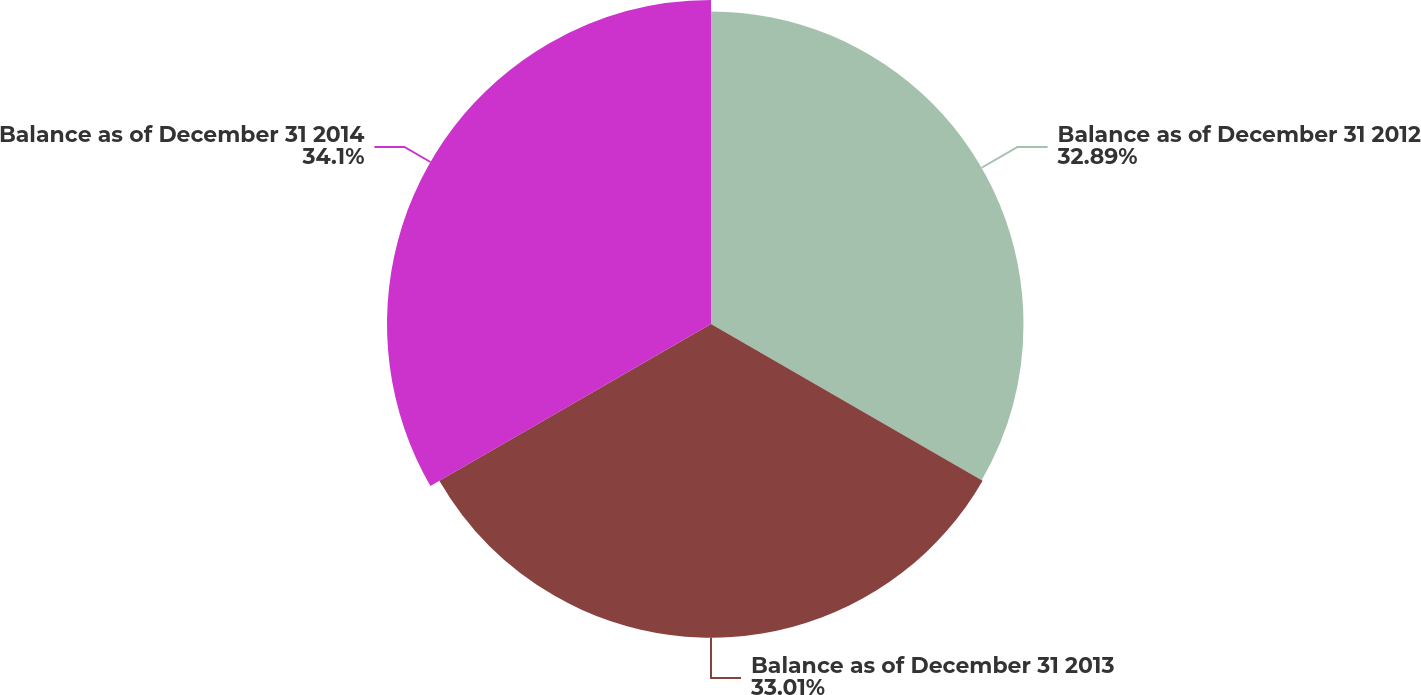Convert chart to OTSL. <chart><loc_0><loc_0><loc_500><loc_500><pie_chart><fcel>Balance as of December 31 2012<fcel>Balance as of December 31 2013<fcel>Balance as of December 31 2014<nl><fcel>32.89%<fcel>33.01%<fcel>34.1%<nl></chart> 